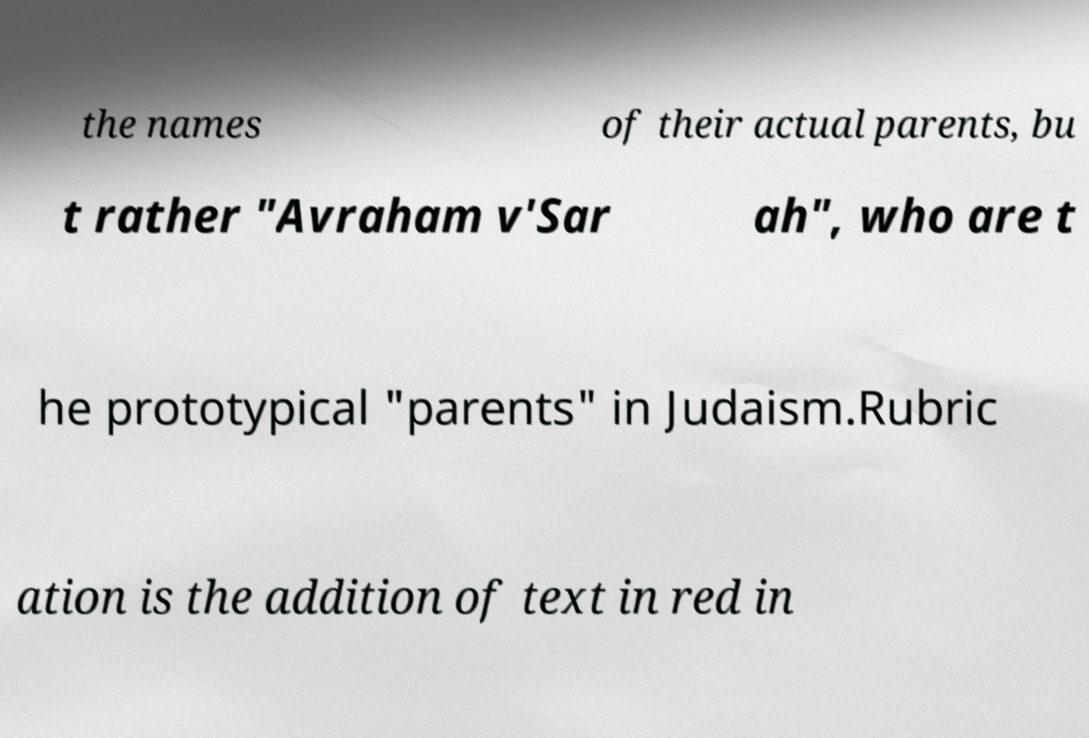Please identify and transcribe the text found in this image. the names of their actual parents, bu t rather "Avraham v'Sar ah", who are t he prototypical "parents" in Judaism.Rubric ation is the addition of text in red in 